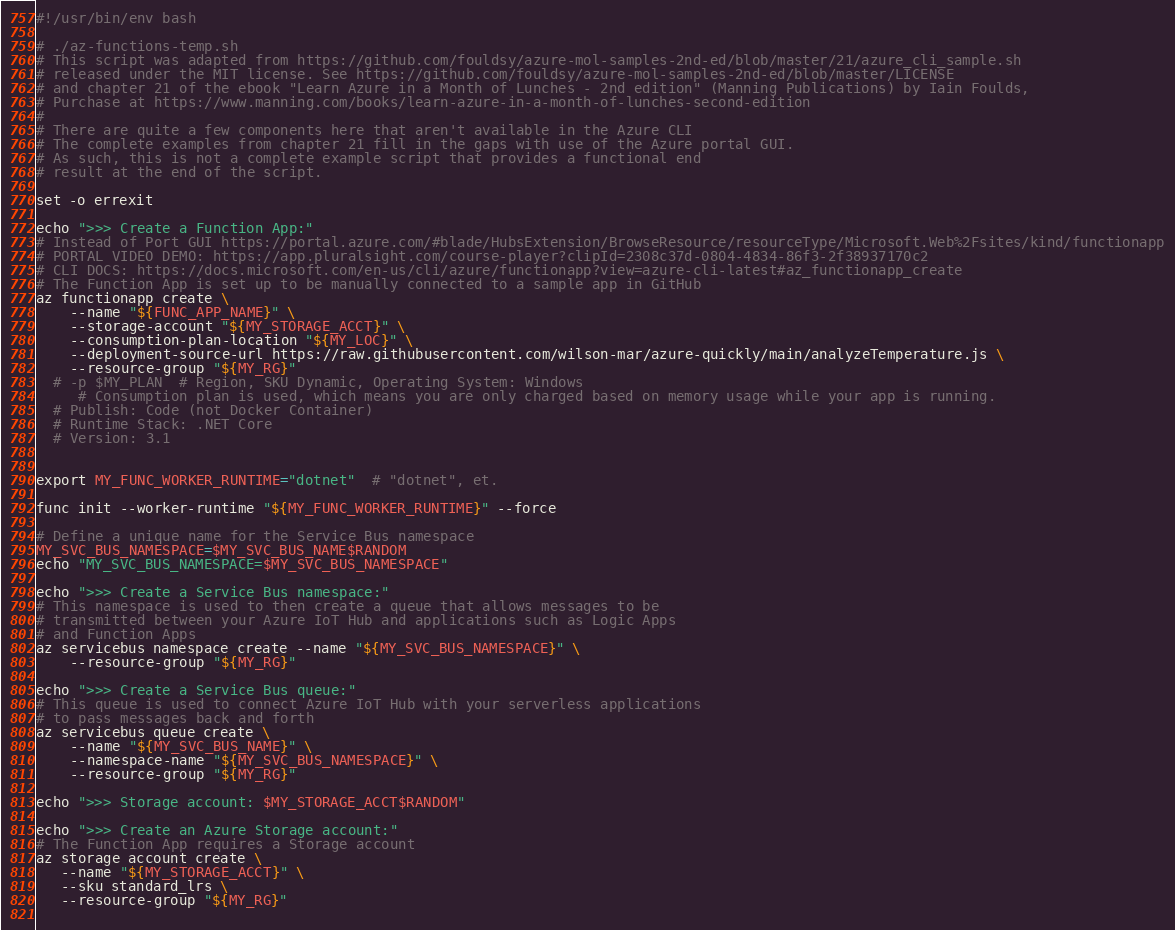Convert code to text. <code><loc_0><loc_0><loc_500><loc_500><_Bash_>#!/usr/bin/env bash

# ./az-functions-temp.sh
# This script was adapted from https://github.com/fouldsy/azure-mol-samples-2nd-ed/blob/master/21/azure_cli_sample.sh
# released under the MIT license. See https://github.com/fouldsy/azure-mol-samples-2nd-ed/blob/master/LICENSE
# and chapter 21 of the ebook "Learn Azure in a Month of Lunches - 2nd edition" (Manning Publications) by Iain Foulds,
# Purchase at https://www.manning.com/books/learn-azure-in-a-month-of-lunches-second-edition
#
# There are quite a few components here that aren't available in the Azure CLI
# The complete examples from chapter 21 fill in the gaps with use of the Azure portal GUI.
# As such, this is not a complete example script that provides a functional end
# result at the end of the script.

set -o errexit

echo ">>> Create a Function App:"
# Instead of Port GUI https://portal.azure.com/#blade/HubsExtension/BrowseResource/resourceType/Microsoft.Web%2Fsites/kind/functionapp
# PORTAL VIDEO DEMO: https://app.pluralsight.com/course-player?clipId=2308c37d-0804-4834-86f3-2f38937170c2
# CLI DOCS: https://docs.microsoft.com/en-us/cli/azure/functionapp?view=azure-cli-latest#az_functionapp_create
# The Function App is set up to be manually connected to a sample app in GitHub
az functionapp create \
    --name "${FUNC_APP_NAME}" \
    --storage-account "${MY_STORAGE_ACCT}" \
    --consumption-plan-location "${MY_LOC}" \
    --deployment-source-url https://raw.githubusercontent.com/wilson-mar/azure-quickly/main/analyzeTemperature.js \
    --resource-group "${MY_RG}"
  # -p $MY_PLAN  # Region, SKU Dynamic, Operating System: Windows
     # Consumption plan is used, which means you are only charged based on memory usage while your app is running. 
  # Publish: Code (not Docker Container)
  # Runtime Stack: .NET Core
  # Version: 3.1
    

export MY_FUNC_WORKER_RUNTIME="dotnet"  # "dotnet", et.

func init --worker-runtime "${MY_FUNC_WORKER_RUNTIME}" --force

# Define a unique name for the Service Bus namespace
MY_SVC_BUS_NAMESPACE=$MY_SVC_BUS_NAME$RANDOM
echo "MY_SVC_BUS_NAMESPACE=$MY_SVC_BUS_NAMESPACE"

echo ">>> Create a Service Bus namespace:"
# This namespace is used to then create a queue that allows messages to be
# transmitted between your Azure IoT Hub and applications such as Logic Apps
# and Function Apps
az servicebus namespace create --name "${MY_SVC_BUS_NAMESPACE}" \
    --resource-group "${MY_RG}"

echo ">>> Create a Service Bus queue:"
# This queue is used to connect Azure IoT Hub with your serverless applications
# to pass messages back and forth
az servicebus queue create \
    --name "${MY_SVC_BUS_NAME}" \
    --namespace-name "${MY_SVC_BUS_NAMESPACE}" \
    --resource-group "${MY_RG}"
    
echo ">>> Storage account: $MY_STORAGE_ACCT$RANDOM"

echo ">>> Create an Azure Storage account:"
# The Function App requires a Storage account
az storage account create \
   --name "${MY_STORAGE_ACCT}" \
   --sku standard_lrs \
   --resource-group "${MY_RG}"
    </code> 